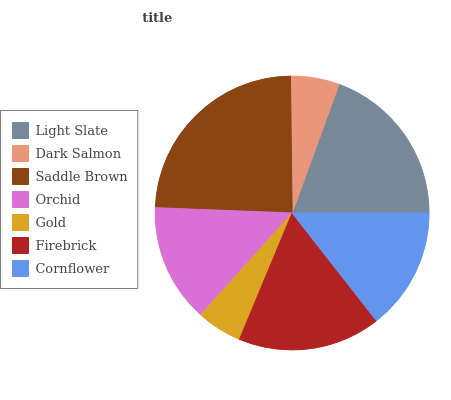Is Gold the minimum?
Answer yes or no. Yes. Is Saddle Brown the maximum?
Answer yes or no. Yes. Is Dark Salmon the minimum?
Answer yes or no. No. Is Dark Salmon the maximum?
Answer yes or no. No. Is Light Slate greater than Dark Salmon?
Answer yes or no. Yes. Is Dark Salmon less than Light Slate?
Answer yes or no. Yes. Is Dark Salmon greater than Light Slate?
Answer yes or no. No. Is Light Slate less than Dark Salmon?
Answer yes or no. No. Is Cornflower the high median?
Answer yes or no. Yes. Is Cornflower the low median?
Answer yes or no. Yes. Is Firebrick the high median?
Answer yes or no. No. Is Light Slate the low median?
Answer yes or no. No. 